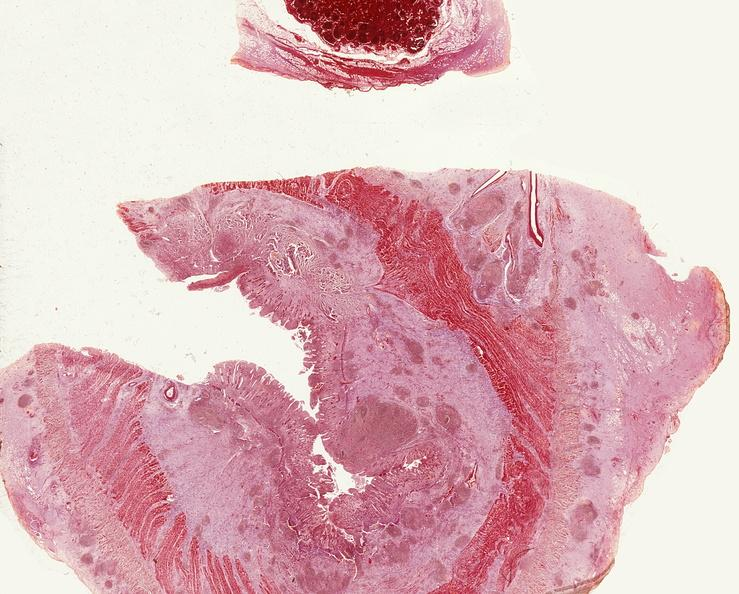does this image show small intestine, regional enteritis?
Answer the question using a single word or phrase. Yes 